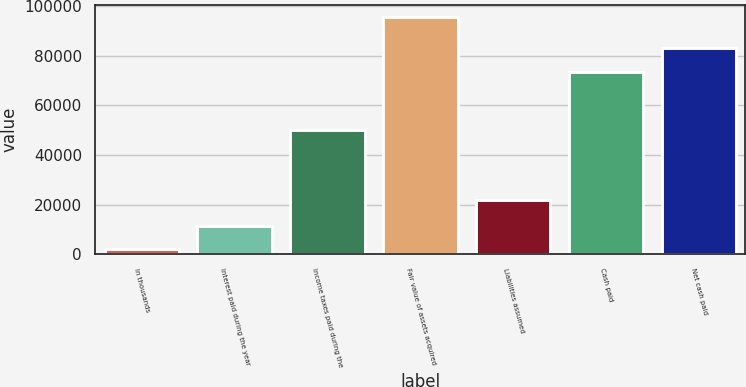Convert chart. <chart><loc_0><loc_0><loc_500><loc_500><bar_chart><fcel>In thousands<fcel>Interest paid during the year<fcel>Income taxes paid during the<fcel>Fair value of assets acquired<fcel>Liabilities assumed<fcel>Cash paid<fcel>Net cash paid<nl><fcel>2007<fcel>11366.3<fcel>49841<fcel>95600<fcel>22000<fcel>73600<fcel>82959.3<nl></chart> 